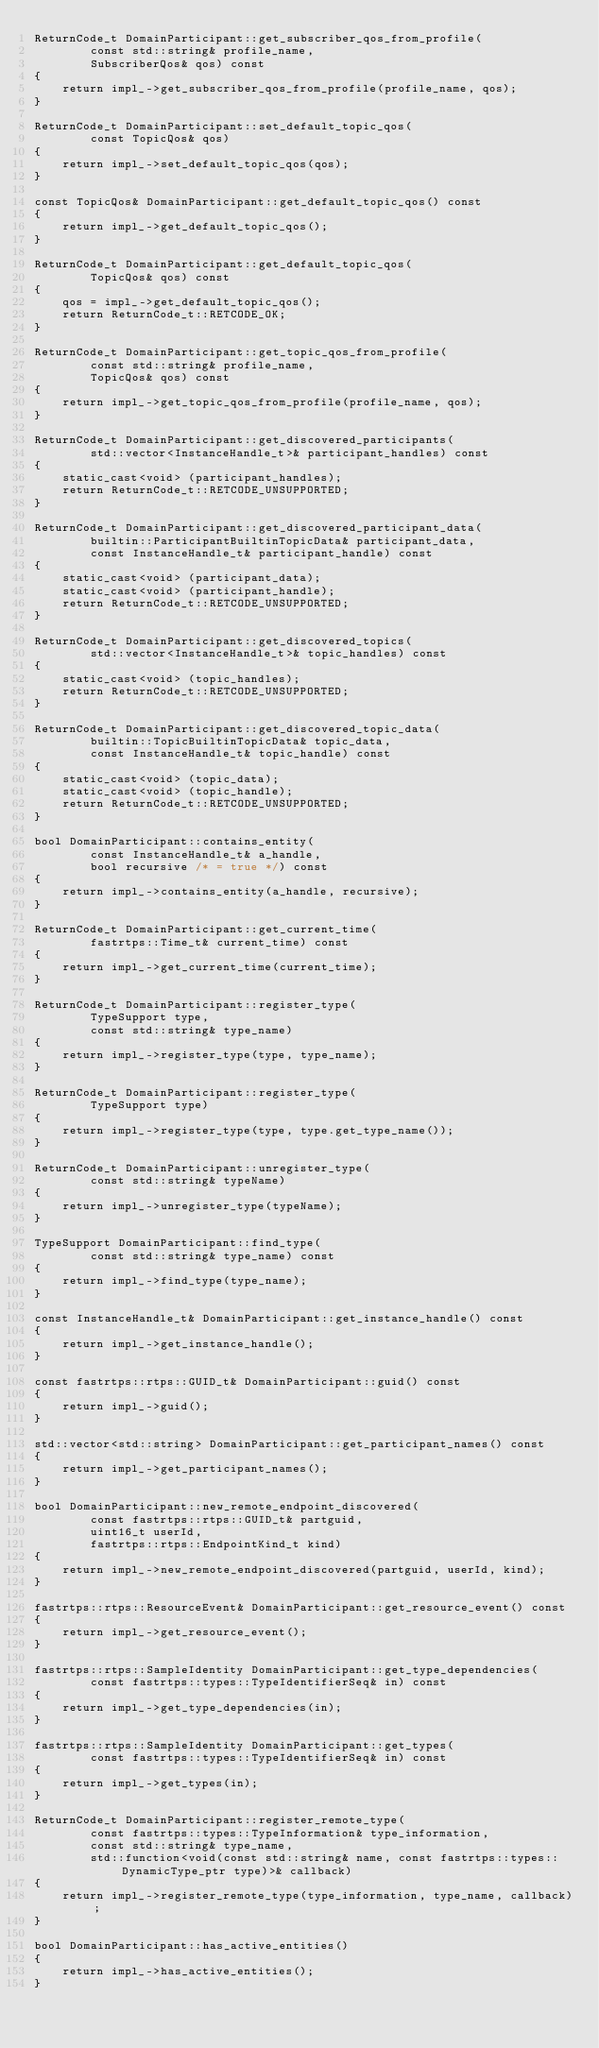<code> <loc_0><loc_0><loc_500><loc_500><_C++_>ReturnCode_t DomainParticipant::get_subscriber_qos_from_profile(
        const std::string& profile_name,
        SubscriberQos& qos) const
{
    return impl_->get_subscriber_qos_from_profile(profile_name, qos);
}

ReturnCode_t DomainParticipant::set_default_topic_qos(
        const TopicQos& qos)
{
    return impl_->set_default_topic_qos(qos);
}

const TopicQos& DomainParticipant::get_default_topic_qos() const
{
    return impl_->get_default_topic_qos();
}

ReturnCode_t DomainParticipant::get_default_topic_qos(
        TopicQos& qos) const
{
    qos = impl_->get_default_topic_qos();
    return ReturnCode_t::RETCODE_OK;
}

ReturnCode_t DomainParticipant::get_topic_qos_from_profile(
        const std::string& profile_name,
        TopicQos& qos) const
{
    return impl_->get_topic_qos_from_profile(profile_name, qos);
}

ReturnCode_t DomainParticipant::get_discovered_participants(
        std::vector<InstanceHandle_t>& participant_handles) const
{
    static_cast<void> (participant_handles);
    return ReturnCode_t::RETCODE_UNSUPPORTED;
}

ReturnCode_t DomainParticipant::get_discovered_participant_data(
        builtin::ParticipantBuiltinTopicData& participant_data,
        const InstanceHandle_t& participant_handle) const
{
    static_cast<void> (participant_data);
    static_cast<void> (participant_handle);
    return ReturnCode_t::RETCODE_UNSUPPORTED;
}

ReturnCode_t DomainParticipant::get_discovered_topics(
        std::vector<InstanceHandle_t>& topic_handles) const
{
    static_cast<void> (topic_handles);
    return ReturnCode_t::RETCODE_UNSUPPORTED;
}

ReturnCode_t DomainParticipant::get_discovered_topic_data(
        builtin::TopicBuiltinTopicData& topic_data,
        const InstanceHandle_t& topic_handle) const
{
    static_cast<void> (topic_data);
    static_cast<void> (topic_handle);
    return ReturnCode_t::RETCODE_UNSUPPORTED;
}

bool DomainParticipant::contains_entity(
        const InstanceHandle_t& a_handle,
        bool recursive /* = true */) const
{
    return impl_->contains_entity(a_handle, recursive);
}

ReturnCode_t DomainParticipant::get_current_time(
        fastrtps::Time_t& current_time) const
{
    return impl_->get_current_time(current_time);
}

ReturnCode_t DomainParticipant::register_type(
        TypeSupport type,
        const std::string& type_name)
{
    return impl_->register_type(type, type_name);
}

ReturnCode_t DomainParticipant::register_type(
        TypeSupport type)
{
    return impl_->register_type(type, type.get_type_name());
}

ReturnCode_t DomainParticipant::unregister_type(
        const std::string& typeName)
{
    return impl_->unregister_type(typeName);
}

TypeSupport DomainParticipant::find_type(
        const std::string& type_name) const
{
    return impl_->find_type(type_name);
}

const InstanceHandle_t& DomainParticipant::get_instance_handle() const
{
    return impl_->get_instance_handle();
}

const fastrtps::rtps::GUID_t& DomainParticipant::guid() const
{
    return impl_->guid();
}

std::vector<std::string> DomainParticipant::get_participant_names() const
{
    return impl_->get_participant_names();
}

bool DomainParticipant::new_remote_endpoint_discovered(
        const fastrtps::rtps::GUID_t& partguid,
        uint16_t userId,
        fastrtps::rtps::EndpointKind_t kind)
{
    return impl_->new_remote_endpoint_discovered(partguid, userId, kind);
}

fastrtps::rtps::ResourceEvent& DomainParticipant::get_resource_event() const
{
    return impl_->get_resource_event();
}

fastrtps::rtps::SampleIdentity DomainParticipant::get_type_dependencies(
        const fastrtps::types::TypeIdentifierSeq& in) const
{
    return impl_->get_type_dependencies(in);
}

fastrtps::rtps::SampleIdentity DomainParticipant::get_types(
        const fastrtps::types::TypeIdentifierSeq& in) const
{
    return impl_->get_types(in);
}

ReturnCode_t DomainParticipant::register_remote_type(
        const fastrtps::types::TypeInformation& type_information,
        const std::string& type_name,
        std::function<void(const std::string& name, const fastrtps::types::DynamicType_ptr type)>& callback)
{
    return impl_->register_remote_type(type_information, type_name, callback);
}

bool DomainParticipant::has_active_entities()
{
    return impl_->has_active_entities();
}
</code> 